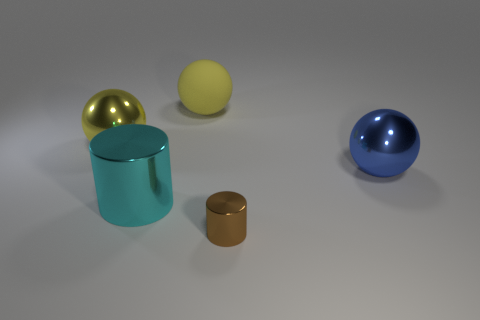Add 4 small metallic things. How many objects exist? 9 Subtract all spheres. How many objects are left? 2 Subtract 0 red balls. How many objects are left? 5 Subtract all large shiny cylinders. Subtract all shiny things. How many objects are left? 0 Add 2 metallic cylinders. How many metallic cylinders are left? 4 Add 4 big cyan matte things. How many big cyan matte things exist? 4 